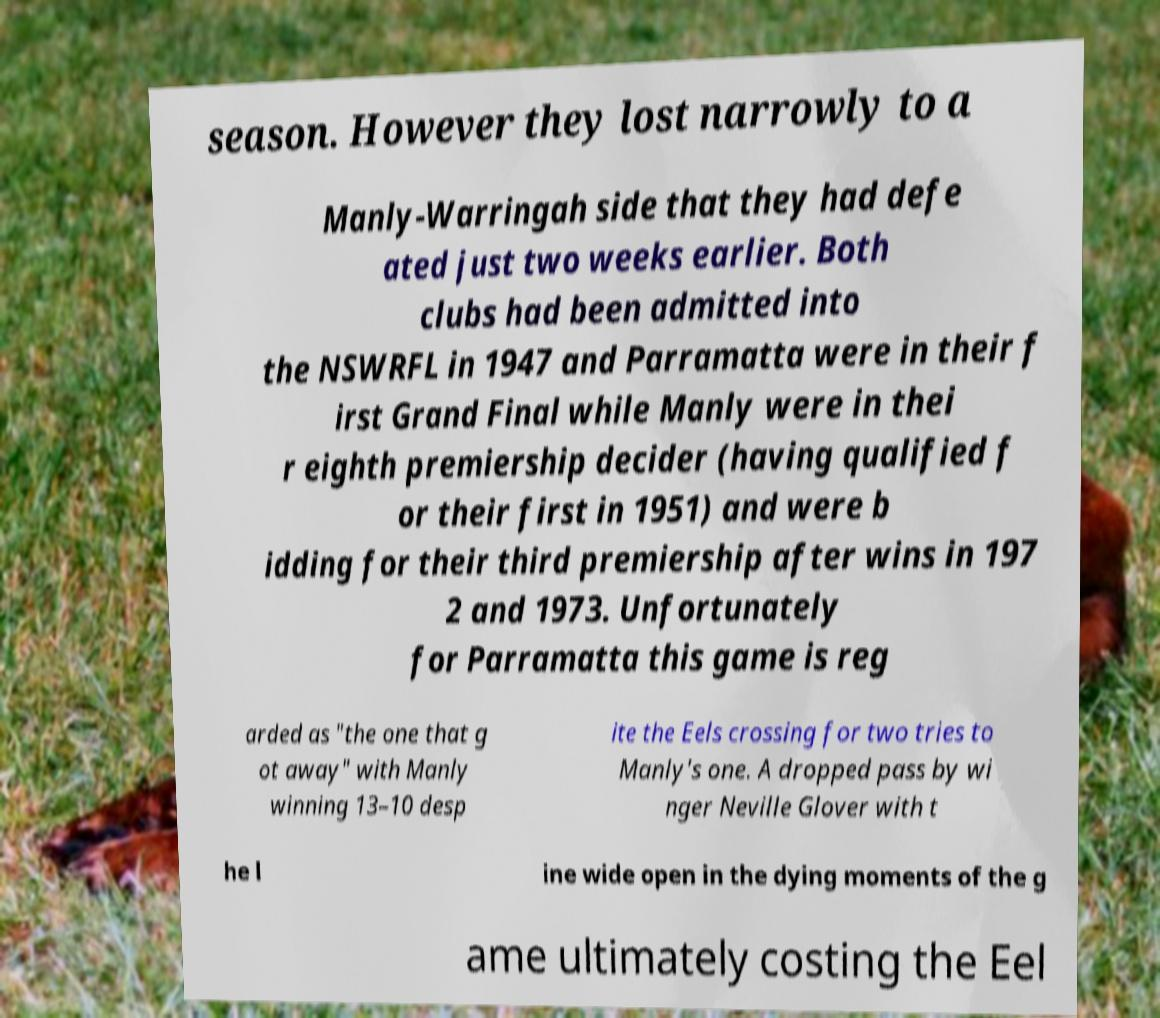Could you extract and type out the text from this image? season. However they lost narrowly to a Manly-Warringah side that they had defe ated just two weeks earlier. Both clubs had been admitted into the NSWRFL in 1947 and Parramatta were in their f irst Grand Final while Manly were in thei r eighth premiership decider (having qualified f or their first in 1951) and were b idding for their third premiership after wins in 197 2 and 1973. Unfortunately for Parramatta this game is reg arded as "the one that g ot away" with Manly winning 13–10 desp ite the Eels crossing for two tries to Manly's one. A dropped pass by wi nger Neville Glover with t he l ine wide open in the dying moments of the g ame ultimately costing the Eel 